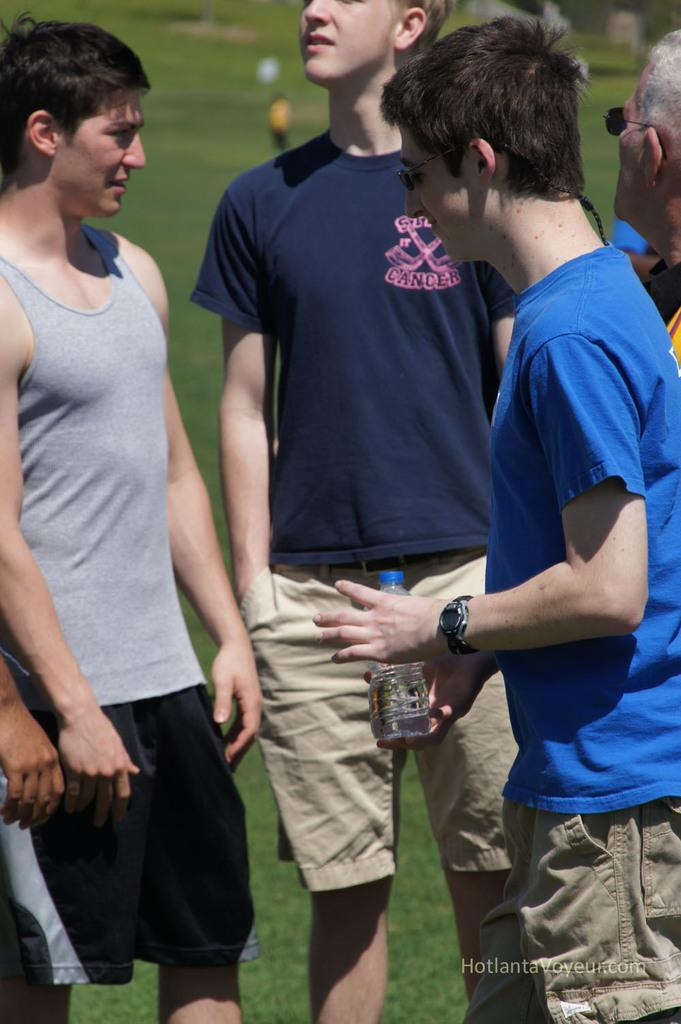How many people are present in the image? There are four people in the image. What is the surface beneath the people's feet? The people are standing on a grass floor. Can you describe what one of the people is holding? One person is holding a bottle in their hands. What invention is the person holding the bottle in the image working on? There is no indication in the image that the person holding the bottle is working on an invention. 